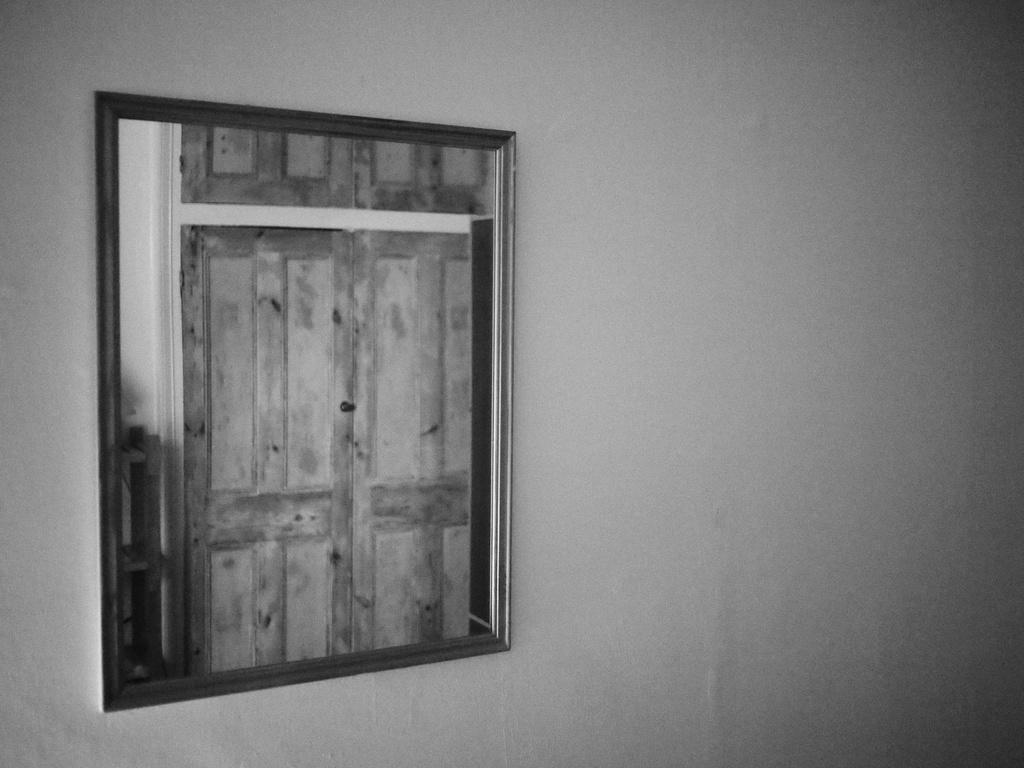Please provide a concise description of this image. This picture is a black and white image. In this image we can see one photo frame with photo attached to the white wall. 